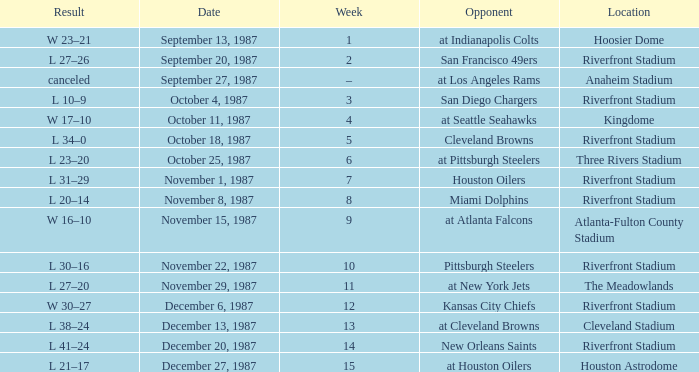What was the result of the game against the Miami Dolphins held at the Riverfront Stadium? L 20–14. 